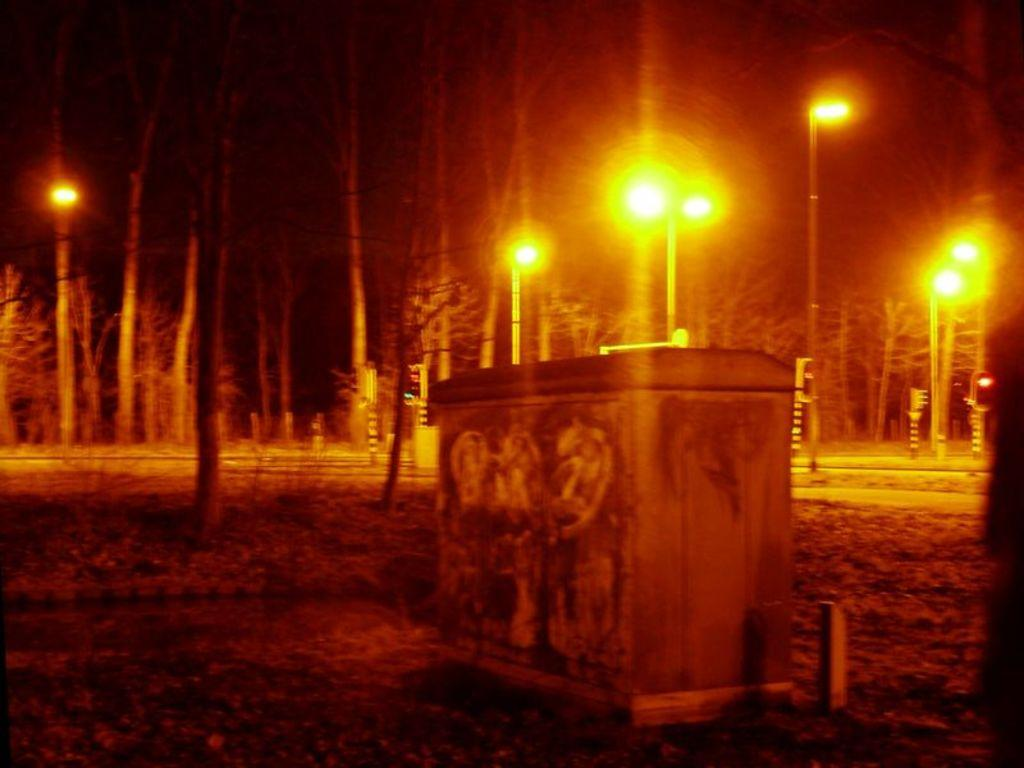What type of furniture is present in the image? There is a wooden cupboard in the image. What other objects can be seen in the image? There are poles and lights visible in the image. What type of natural elements are present in the image? There are trees in the image. What idea does the expert have about the rifle in the image? There is no expert, idea, or rifle present in the image. 